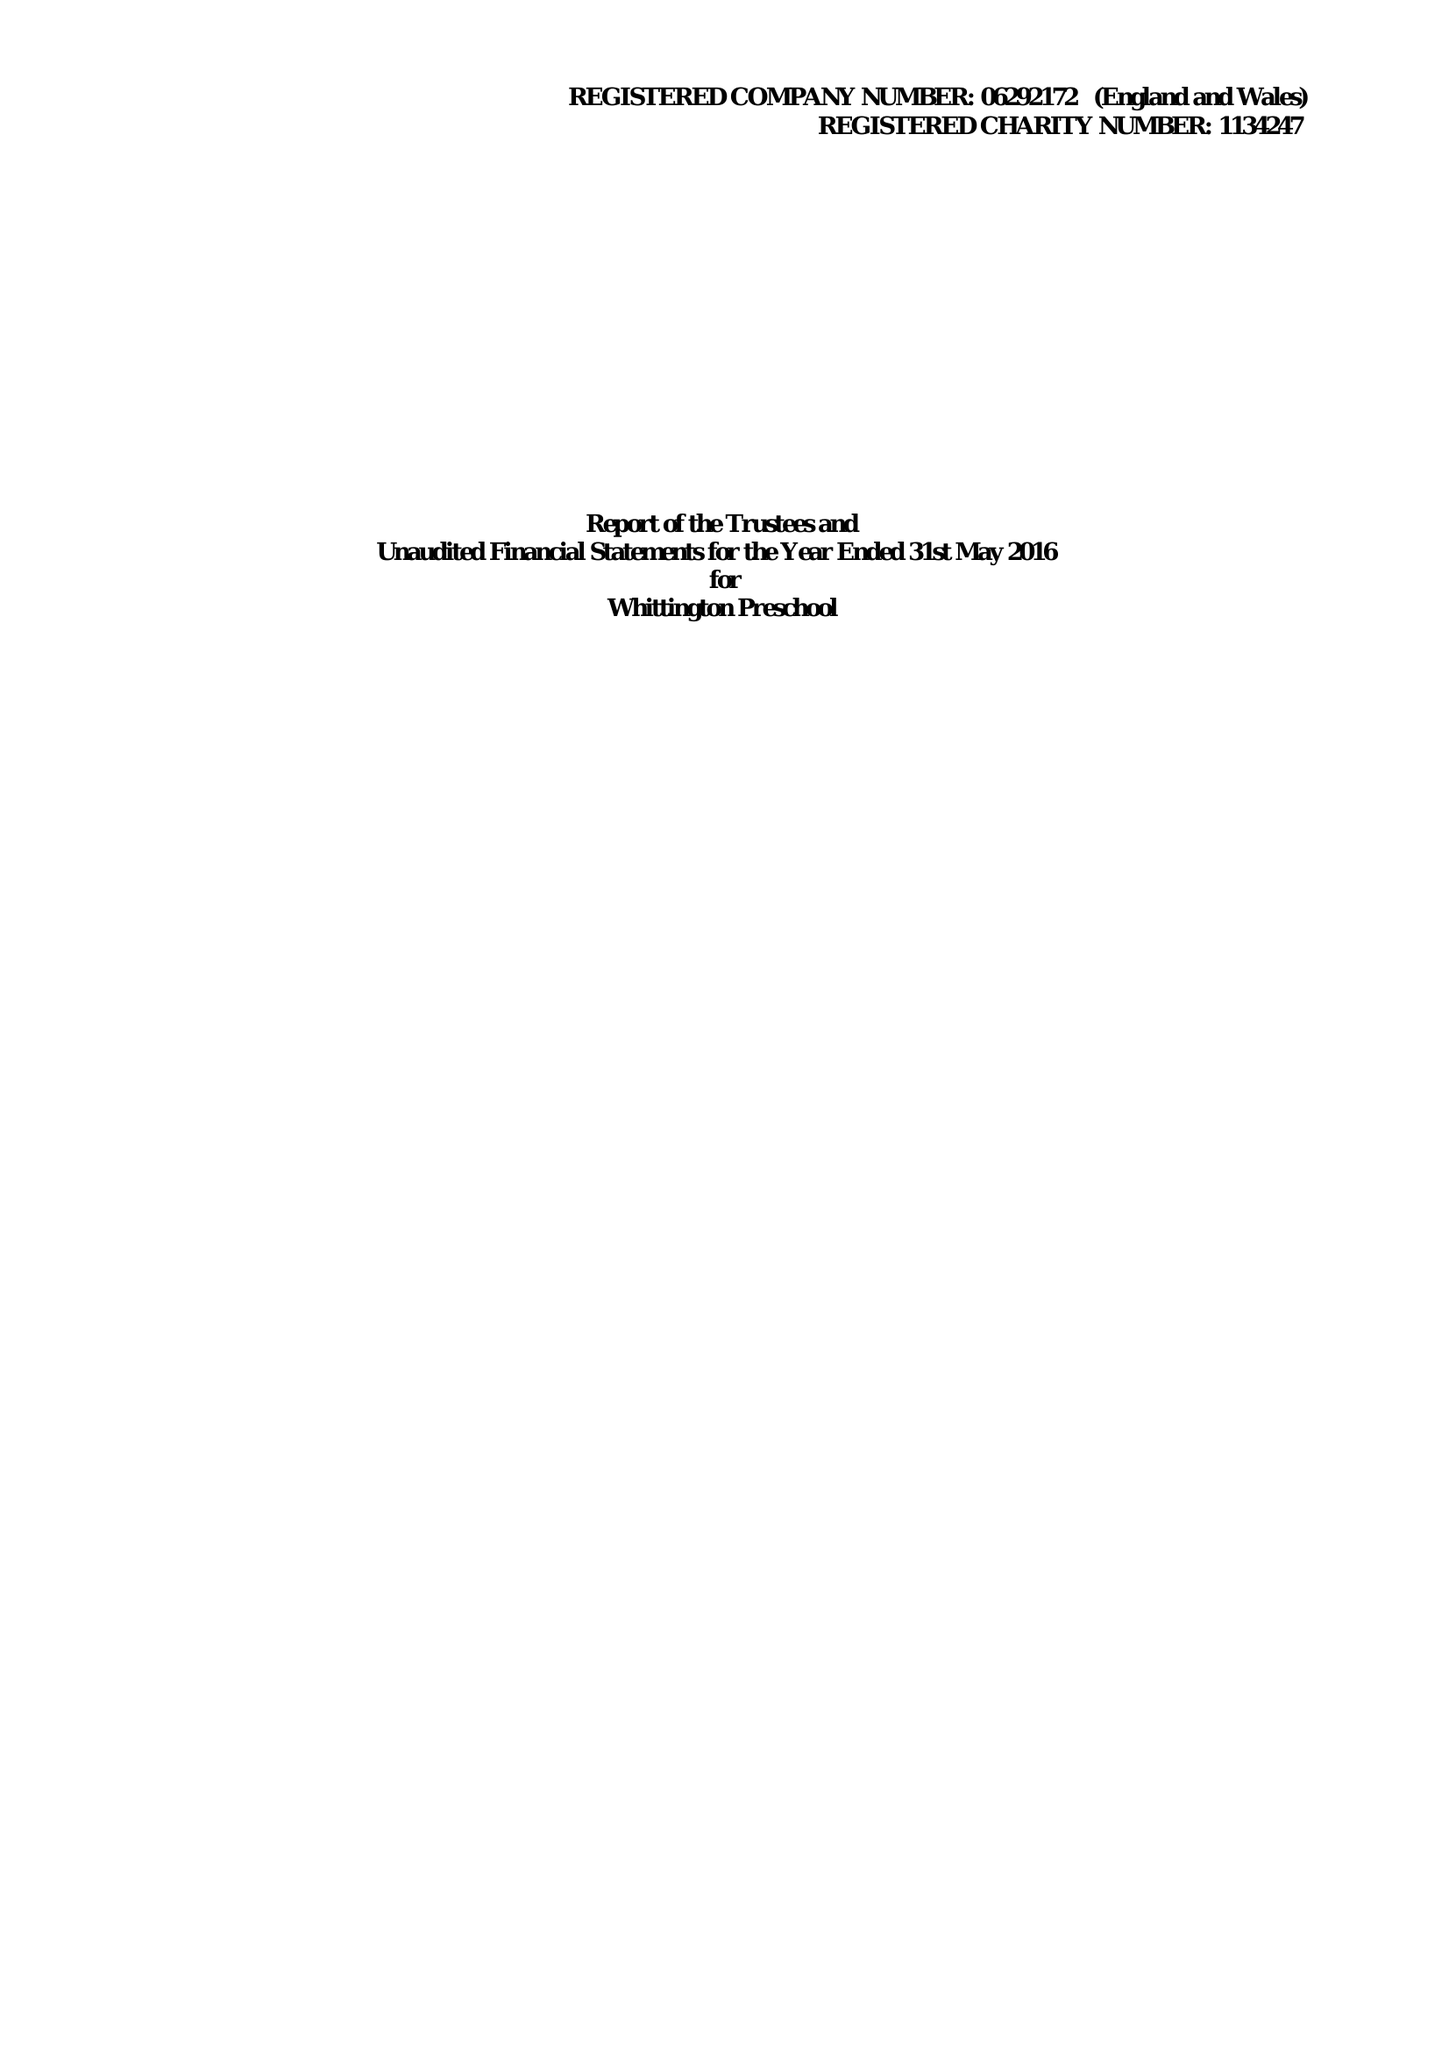What is the value for the charity_number?
Answer the question using a single word or phrase. 1134247 